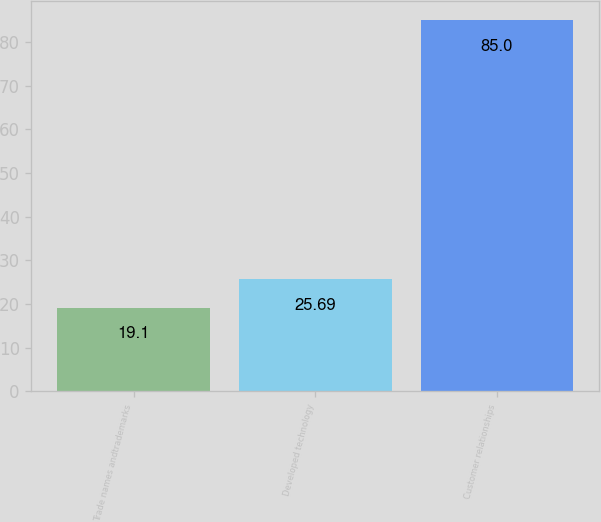Convert chart to OTSL. <chart><loc_0><loc_0><loc_500><loc_500><bar_chart><fcel>Trade names andtrademarks<fcel>Developed technology<fcel>Customer relationships<nl><fcel>19.1<fcel>25.69<fcel>85<nl></chart> 